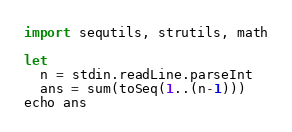Convert code to text. <code><loc_0><loc_0><loc_500><loc_500><_Nim_>import sequtils, strutils, math

let
  n = stdin.readLine.parseInt
  ans = sum(toSeq(1..(n-1)))
echo ans</code> 